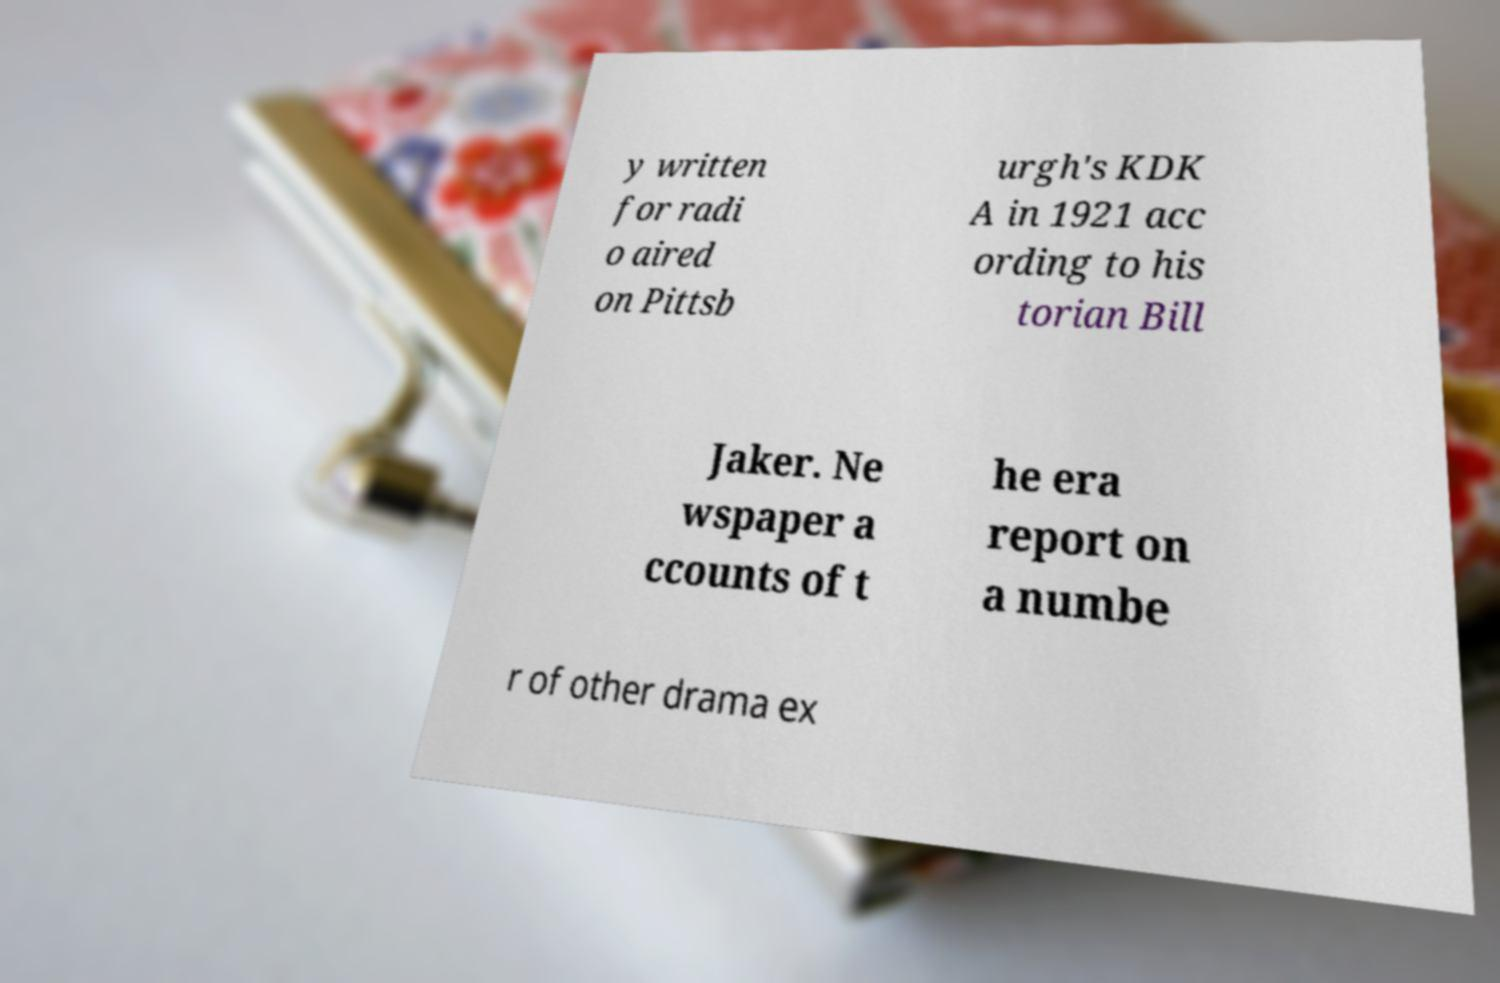Can you accurately transcribe the text from the provided image for me? y written for radi o aired on Pittsb urgh's KDK A in 1921 acc ording to his torian Bill Jaker. Ne wspaper a ccounts of t he era report on a numbe r of other drama ex 